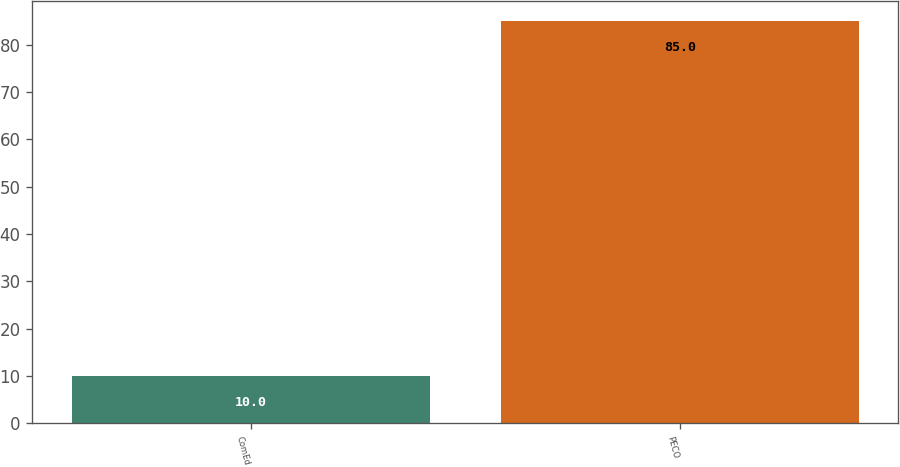Convert chart to OTSL. <chart><loc_0><loc_0><loc_500><loc_500><bar_chart><fcel>ComEd<fcel>PECO<nl><fcel>10<fcel>85<nl></chart> 